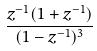Convert formula to latex. <formula><loc_0><loc_0><loc_500><loc_500>\frac { z ^ { - 1 } ( 1 + z ^ { - 1 } ) } { ( 1 - z ^ { - 1 } ) ^ { 3 } }</formula> 